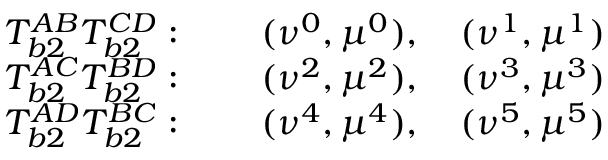<formula> <loc_0><loc_0><loc_500><loc_500>\begin{array} { c c } { T _ { b 2 } ^ { A B } T _ { b 2 } ^ { C D } \colon \quad ( \nu ^ { 0 } , \mu ^ { 0 } ) , \quad ( \nu ^ { 1 } , \mu ^ { 1 } ) } \\ { T _ { b 2 } ^ { A C } T _ { b 2 } ^ { B D } \colon \quad ( \nu ^ { 2 } , \mu ^ { 2 } ) , \quad ( \nu ^ { 3 } , \mu ^ { 3 } ) } \\ { T _ { b 2 } ^ { A D } T _ { b 2 } ^ { B C } \colon \quad ( \nu ^ { 4 } , \mu ^ { 4 } ) , \quad ( \nu ^ { 5 } , \mu ^ { 5 } ) } \end{array}</formula> 